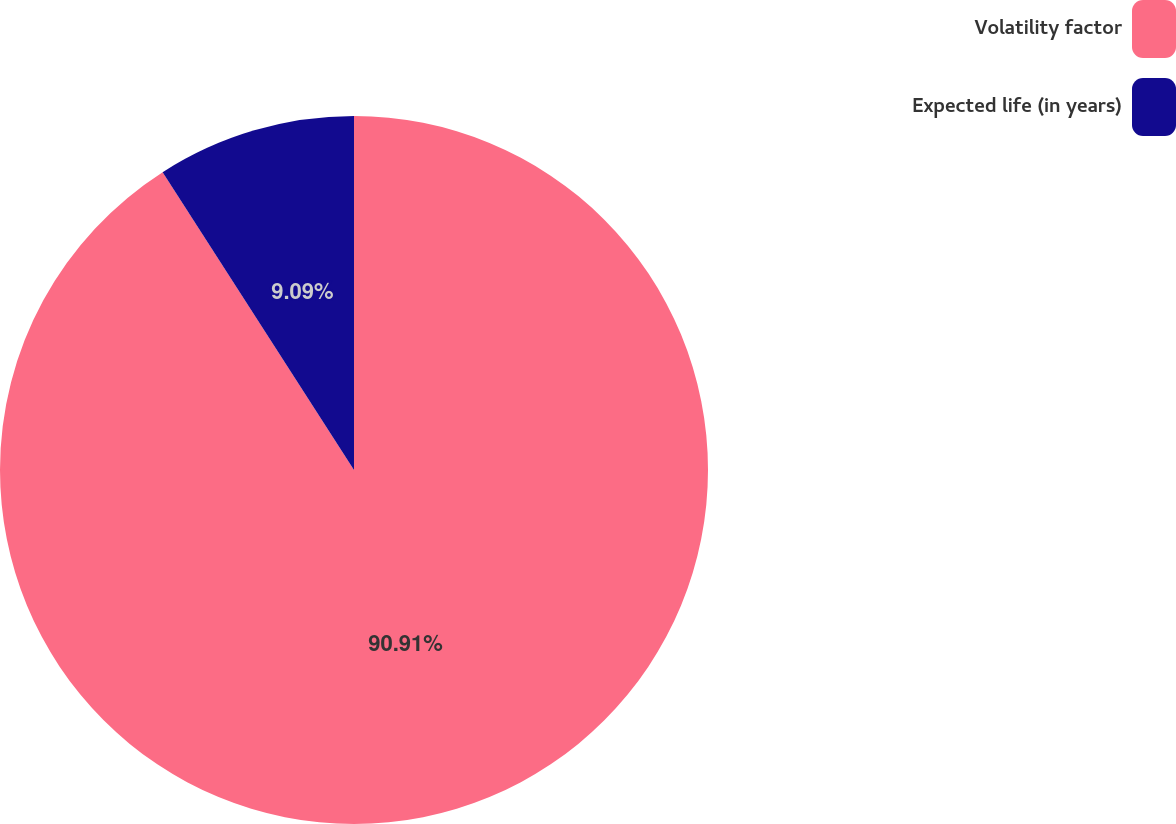Convert chart. <chart><loc_0><loc_0><loc_500><loc_500><pie_chart><fcel>Volatility factor<fcel>Expected life (in years)<nl><fcel>90.91%<fcel>9.09%<nl></chart> 